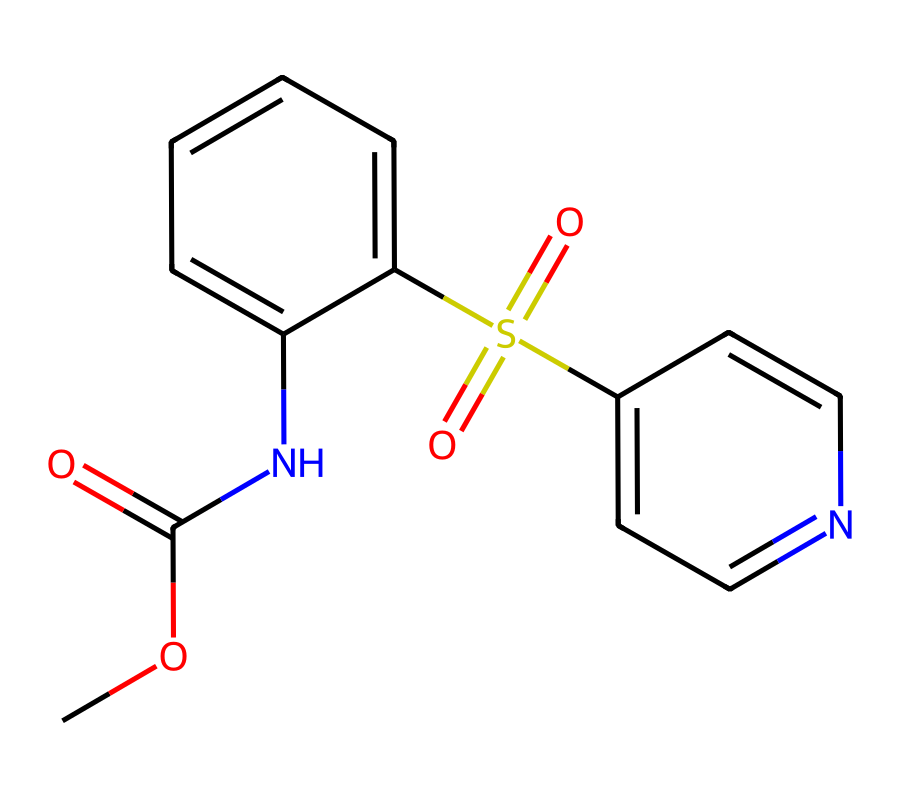What is the molecular formula of this compound? By counting the number of carbon (C), hydrogen (H), nitrogen (N), oxygen (O), and sulfur (S) atoms in the SMILES representation, we identify that there are 13 carbon, 14 hydrogen, 2 nitrogen, 3 oxygen, and 1 sulfur. Therefore, the molecular formula is C13H14N2O3S.
Answer: C13H14N2O3S How many rings are present in the structure? Analyzing the SMILES, there are two indicators of ring structures (C1 and C2), showing that there are two distinct rings in the compound.
Answer: 2 What type of functional groups are present in this drug? In the chemical representation, we can identify an amide (–C(=O)N–), a sulfonyl (–S(=O)(=O)–), and an ester (–C(=O)O–) functional group present in the compound.
Answer: amide, sulfonyl, ester Does this compound contain any nitrogen atoms? A quick examination of the structure shows the presence of two nitrogen atoms within the rings, therefore we can conclude that it does contain nitrogen.
Answer: yes What might be the pharmacological target of this drug based on its structure? Given that the compound contains a sulfonyl group and nitrogen-containing heterocycles, it is likely that this drug targets neurotransmitter systems or neuronal function, often associated with cognitive enhancement drugs.
Answer: neurotransmitter systems 